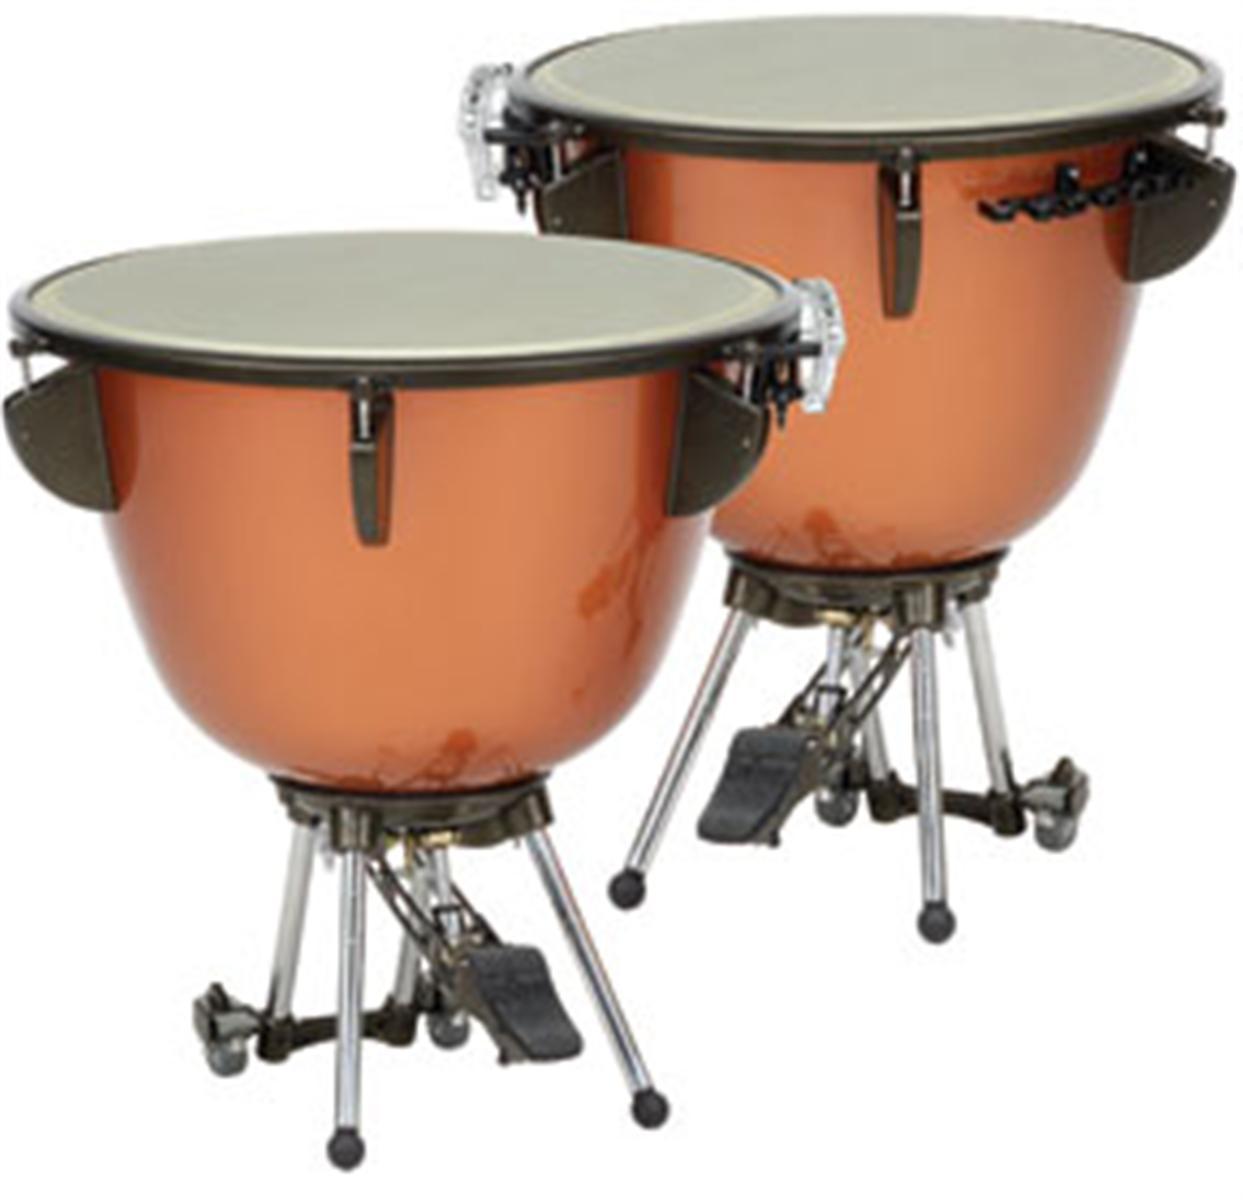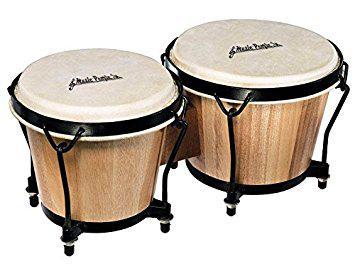The first image is the image on the left, the second image is the image on the right. Given the left and right images, does the statement "There are more drums in the image on the left." hold true? Answer yes or no. No. 